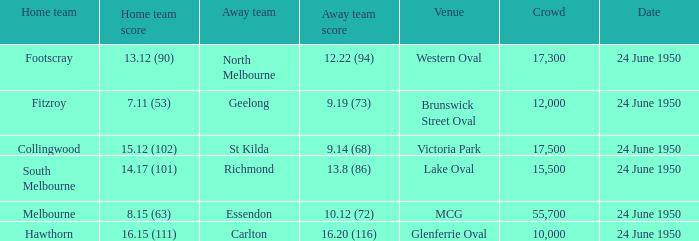When took place the game in which the away team reached 1 24 June 1950. 